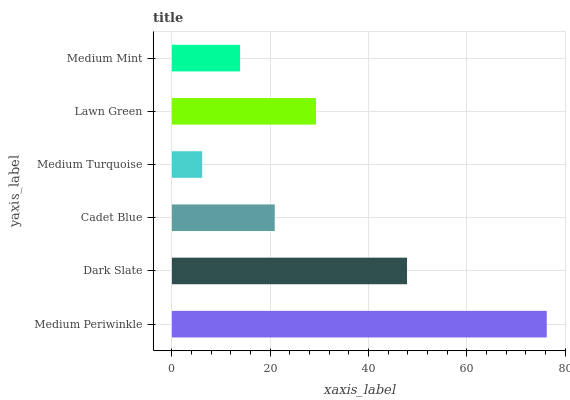Is Medium Turquoise the minimum?
Answer yes or no. Yes. Is Medium Periwinkle the maximum?
Answer yes or no. Yes. Is Dark Slate the minimum?
Answer yes or no. No. Is Dark Slate the maximum?
Answer yes or no. No. Is Medium Periwinkle greater than Dark Slate?
Answer yes or no. Yes. Is Dark Slate less than Medium Periwinkle?
Answer yes or no. Yes. Is Dark Slate greater than Medium Periwinkle?
Answer yes or no. No. Is Medium Periwinkle less than Dark Slate?
Answer yes or no. No. Is Lawn Green the high median?
Answer yes or no. Yes. Is Cadet Blue the low median?
Answer yes or no. Yes. Is Medium Mint the high median?
Answer yes or no. No. Is Dark Slate the low median?
Answer yes or no. No. 